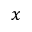<formula> <loc_0><loc_0><loc_500><loc_500>x</formula> 